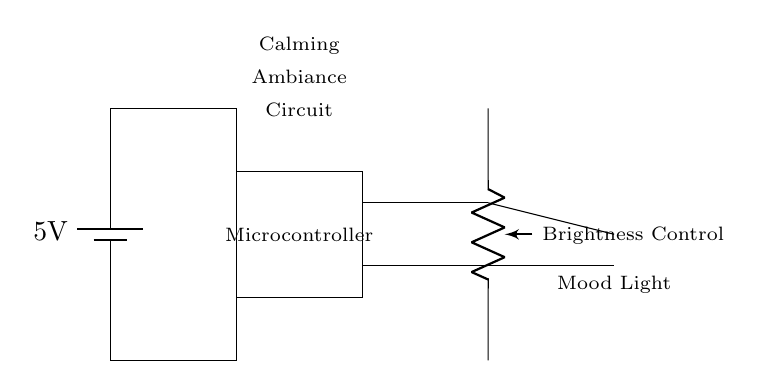What is the voltage of the power supply? The voltage of the power supply is indicated as 5 volts in the circuit diagram. It is marked next to the battery symbol.
Answer: 5 volts What component is used for brightness control? The component used for brightness control is a potentiometer, which is labeled in the diagram. It allows the user to adjust the brightness of the LED mood light.
Answer: Potentiometer How many main components are in the circuit? The main components in this circuit include a battery, microcontroller, potentiometer, and LED. Counting these elements gives a total of four main components.
Answer: Four What color is the mood light LED? The LED mood light is depicted in red color in the circuit diagram. The LED icon is shown in red and is specifically identified as a mood light.
Answer: Red How is the microcontroller connected in the circuit? The microcontroller is connected to both the battery and the LED through the vertical connections, allowing it to control the LED based on the brightness setting from the potentiometer.
Answer: In series What is the role of the microcontroller in this circuit? The microcontroller's role is to process input from the potentiometer and adjust the power delivered to the LED, thereby controlling its brightness to create a calming ambiance.
Answer: Control brightness 